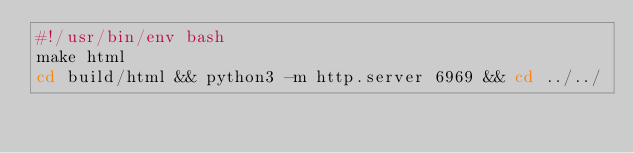<code> <loc_0><loc_0><loc_500><loc_500><_Bash_>#!/usr/bin/env bash
make html
cd build/html && python3 -m http.server 6969 && cd ../../</code> 